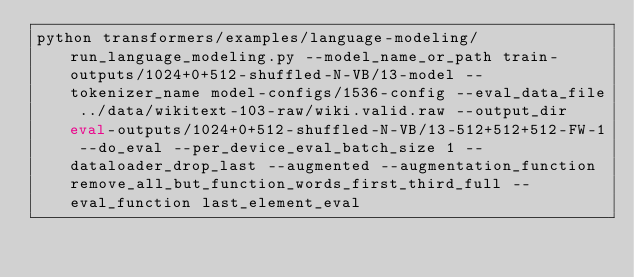<code> <loc_0><loc_0><loc_500><loc_500><_Bash_>python transformers/examples/language-modeling/run_language_modeling.py --model_name_or_path train-outputs/1024+0+512-shuffled-N-VB/13-model --tokenizer_name model-configs/1536-config --eval_data_file ../data/wikitext-103-raw/wiki.valid.raw --output_dir eval-outputs/1024+0+512-shuffled-N-VB/13-512+512+512-FW-1 --do_eval --per_device_eval_batch_size 1 --dataloader_drop_last --augmented --augmentation_function remove_all_but_function_words_first_third_full --eval_function last_element_eval</code> 